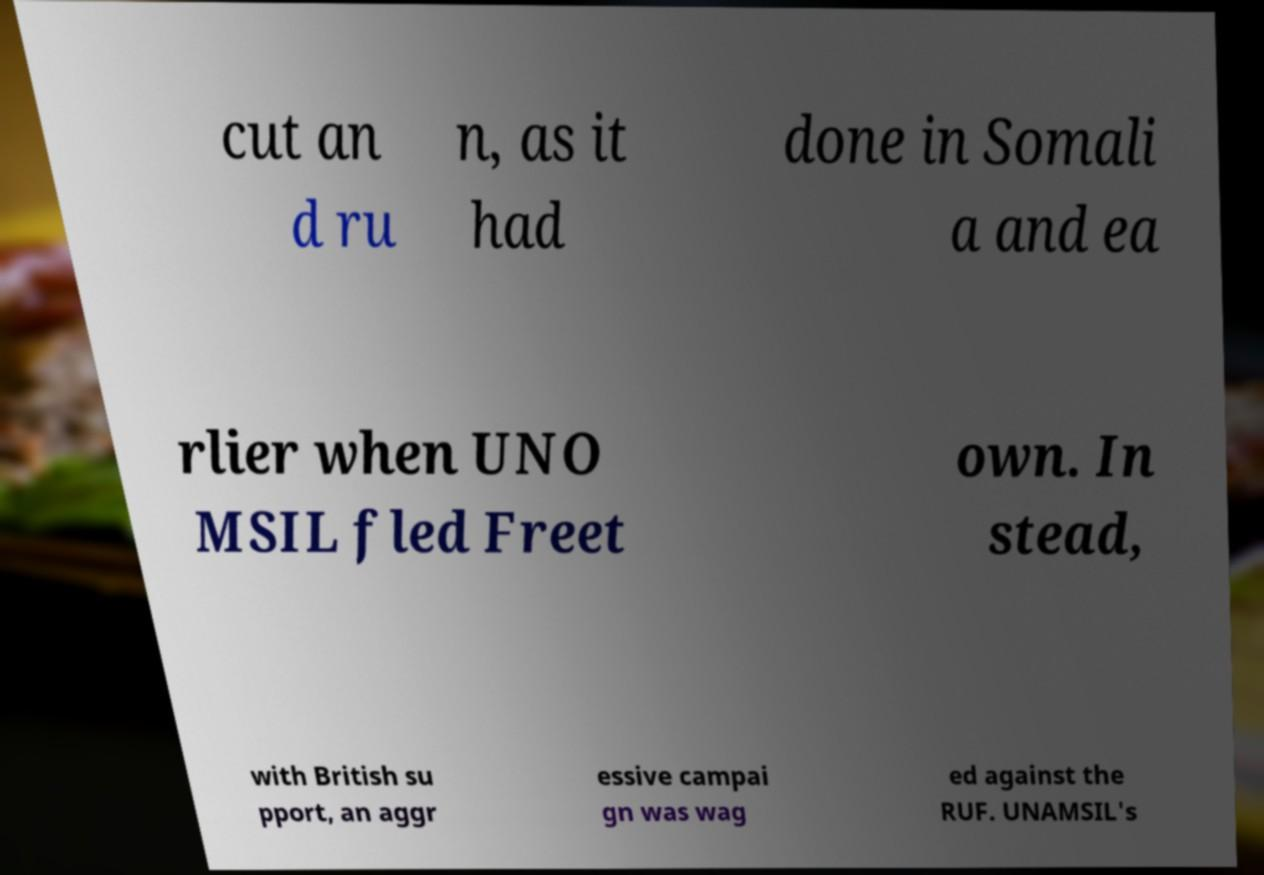Please read and relay the text visible in this image. What does it say? cut an d ru n, as it had done in Somali a and ea rlier when UNO MSIL fled Freet own. In stead, with British su pport, an aggr essive campai gn was wag ed against the RUF. UNAMSIL's 